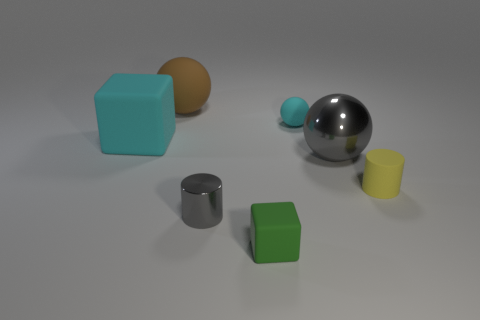Subtract all small cyan spheres. How many spheres are left? 2 Add 3 large gray metal objects. How many objects exist? 10 Subtract 2 cylinders. How many cylinders are left? 0 Subtract all cyan balls. How many balls are left? 2 Subtract all yellow blocks. How many gray cylinders are left? 1 Subtract 0 gray blocks. How many objects are left? 7 Subtract all cylinders. How many objects are left? 5 Subtract all green cylinders. Subtract all gray blocks. How many cylinders are left? 2 Subtract all brown spheres. Subtract all small yellow shiny blocks. How many objects are left? 6 Add 5 big rubber spheres. How many big rubber spheres are left? 6 